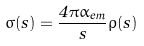<formula> <loc_0><loc_0><loc_500><loc_500>\sigma ( s ) = \frac { 4 \pi \alpha _ { e m } } { s } \rho ( s )</formula> 